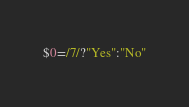Convert code to text. <code><loc_0><loc_0><loc_500><loc_500><_Awk_>$0=/7/?"Yes":"No"</code> 